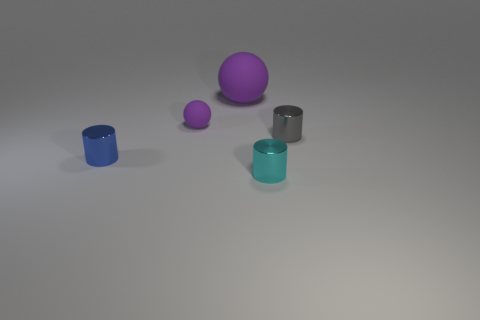Subtract all tiny gray cylinders. How many cylinders are left? 2 Subtract 1 cylinders. How many cylinders are left? 2 Add 3 blue metal cylinders. How many objects exist? 8 Subtract 0 red spheres. How many objects are left? 5 Subtract all cylinders. How many objects are left? 2 Subtract all gray cylinders. Subtract all brown spheres. How many cylinders are left? 2 Subtract all cylinders. Subtract all rubber objects. How many objects are left? 0 Add 1 tiny purple matte things. How many tiny purple matte things are left? 2 Add 2 small matte cylinders. How many small matte cylinders exist? 2 